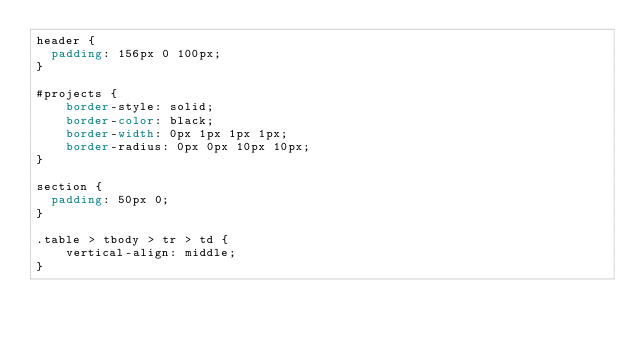Convert code to text. <code><loc_0><loc_0><loc_500><loc_500><_CSS_>header {
  padding: 156px 0 100px;
}

#projects {
    border-style: solid;
    border-color: black;
    border-width: 0px 1px 1px 1px;
    border-radius: 0px 0px 10px 10px;
}

section {
  padding: 50px 0;
}

.table > tbody > tr > td {
    vertical-align: middle;
}

</code> 